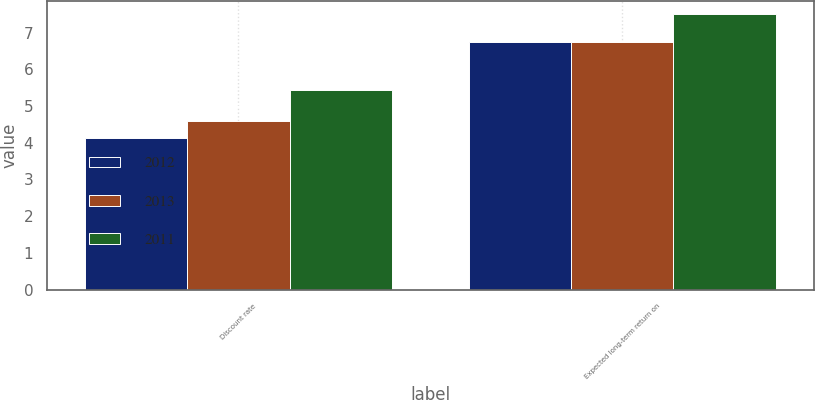Convert chart to OTSL. <chart><loc_0><loc_0><loc_500><loc_500><stacked_bar_chart><ecel><fcel>Discount rate<fcel>Expected long-term return on<nl><fcel>2012<fcel>4.12<fcel>6.75<nl><fcel>2013<fcel>4.59<fcel>6.75<nl><fcel>2011<fcel>5.44<fcel>7.5<nl></chart> 